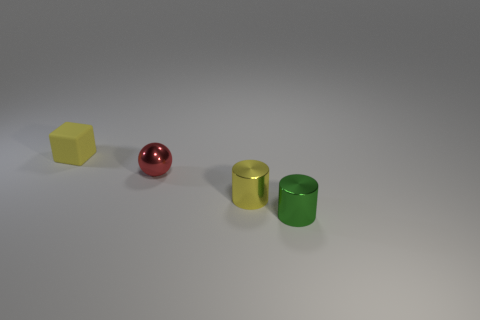Is there a pattern to how the objects are arranged? The objects are arranged in a linear fashion with equal spacing, which creates a sense of order and balance within the composition. 